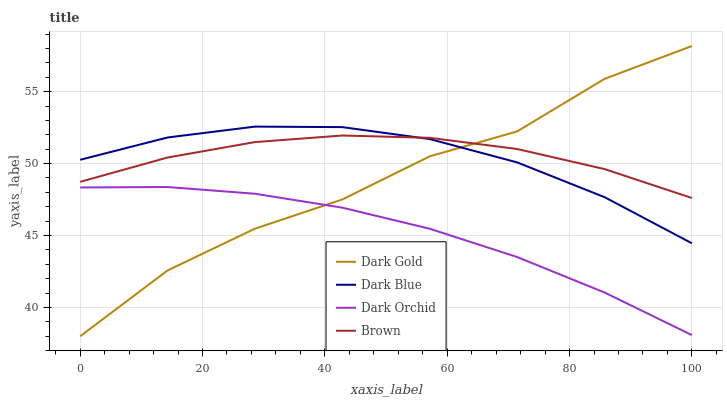Does Dark Orchid have the minimum area under the curve?
Answer yes or no. Yes. Does Brown have the maximum area under the curve?
Answer yes or no. Yes. Does Brown have the minimum area under the curve?
Answer yes or no. No. Does Dark Orchid have the maximum area under the curve?
Answer yes or no. No. Is Dark Orchid the smoothest?
Answer yes or no. Yes. Is Dark Gold the roughest?
Answer yes or no. Yes. Is Brown the smoothest?
Answer yes or no. No. Is Brown the roughest?
Answer yes or no. No. Does Dark Gold have the lowest value?
Answer yes or no. Yes. Does Dark Orchid have the lowest value?
Answer yes or no. No. Does Dark Gold have the highest value?
Answer yes or no. Yes. Does Brown have the highest value?
Answer yes or no. No. Is Dark Orchid less than Dark Blue?
Answer yes or no. Yes. Is Brown greater than Dark Orchid?
Answer yes or no. Yes. Does Dark Gold intersect Dark Orchid?
Answer yes or no. Yes. Is Dark Gold less than Dark Orchid?
Answer yes or no. No. Is Dark Gold greater than Dark Orchid?
Answer yes or no. No. Does Dark Orchid intersect Dark Blue?
Answer yes or no. No. 